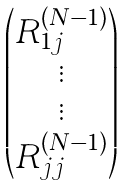Convert formula to latex. <formula><loc_0><loc_0><loc_500><loc_500>\begin{pmatrix} R _ { 1 j } ^ { ( N - 1 ) } \\ \vdots \\ \vdots \\ R _ { j j } ^ { ( N - 1 ) } \end{pmatrix}</formula> 